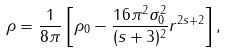Convert formula to latex. <formula><loc_0><loc_0><loc_500><loc_500>\rho = \frac { 1 } { 8 \pi } \left [ \rho _ { 0 } - \frac { 1 6 \pi ^ { 2 } \sigma _ { 0 } ^ { 2 } } { ( s + 3 ) ^ { 2 } } r ^ { 2 s + 2 } \right ] ,</formula> 